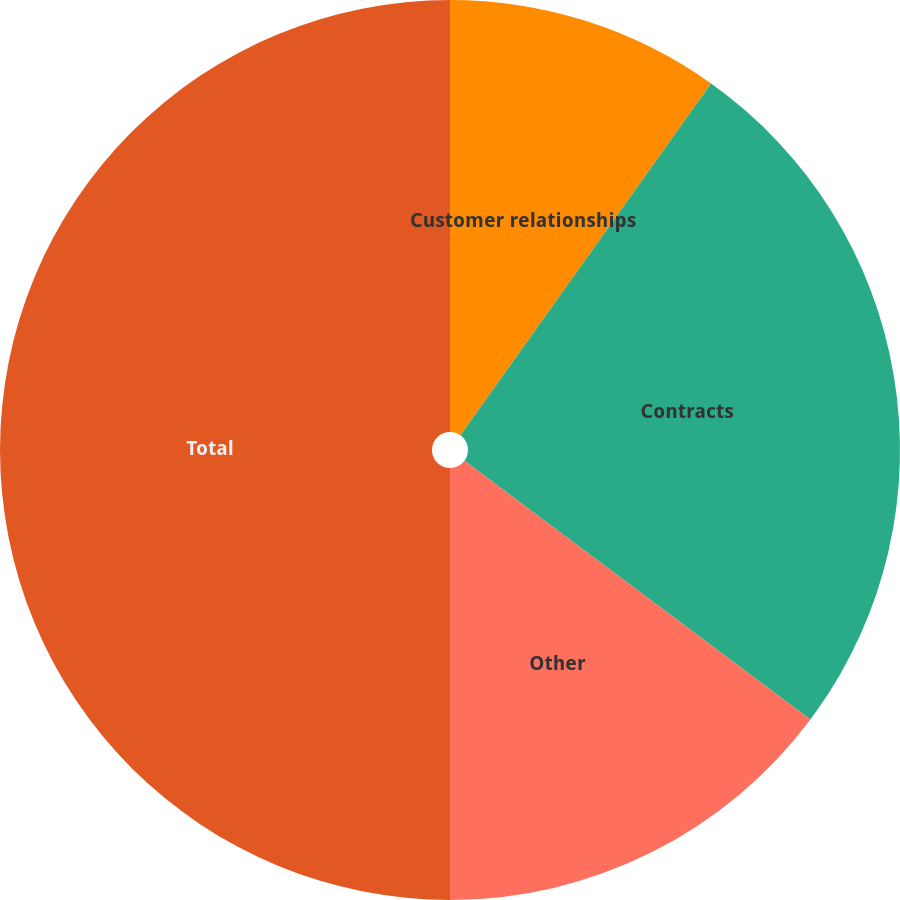<chart> <loc_0><loc_0><loc_500><loc_500><pie_chart><fcel>Customer relationships<fcel>Contracts<fcel>Other<fcel>Total<nl><fcel>9.85%<fcel>25.37%<fcel>14.78%<fcel>50.0%<nl></chart> 